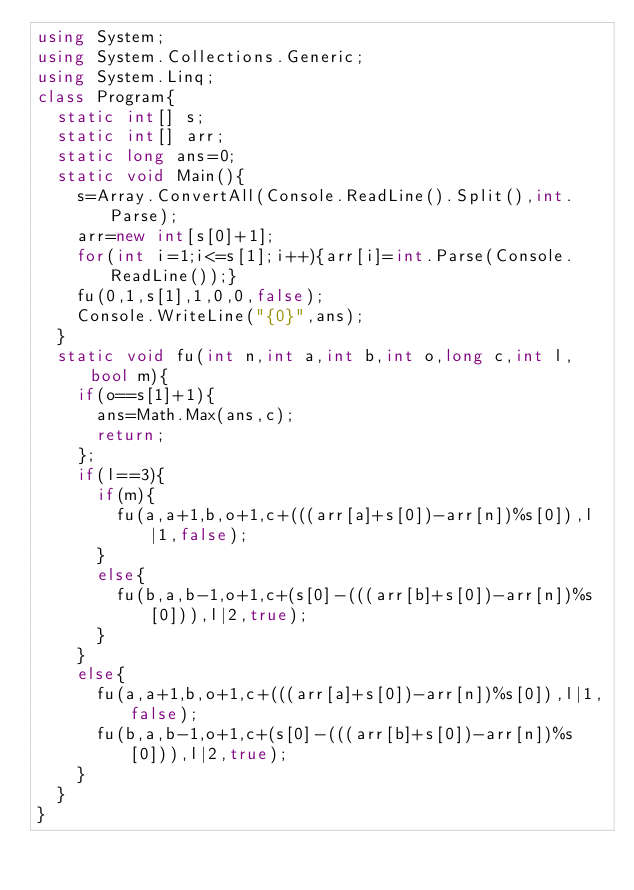<code> <loc_0><loc_0><loc_500><loc_500><_C#_>using System;
using System.Collections.Generic;
using System.Linq;
class Program{
	static int[] s;
	static int[] arr;
	static long ans=0;
	static void Main(){
		s=Array.ConvertAll(Console.ReadLine().Split(),int.Parse);
		arr=new int[s[0]+1];
		for(int i=1;i<=s[1];i++){arr[i]=int.Parse(Console.ReadLine());}
		fu(0,1,s[1],1,0,0,false);
		Console.WriteLine("{0}",ans);
	}
	static void fu(int n,int a,int b,int o,long c,int l,bool m){
		if(o==s[1]+1){
			ans=Math.Max(ans,c);
			return;
		};
		if(l==3){
			if(m){
				fu(a,a+1,b,o+1,c+(((arr[a]+s[0])-arr[n])%s[0]),l|1,false);
			}
			else{
				fu(b,a,b-1,o+1,c+(s[0]-(((arr[b]+s[0])-arr[n])%s[0])),l|2,true);
			}
		}
		else{
			fu(a,a+1,b,o+1,c+(((arr[a]+s[0])-arr[n])%s[0]),l|1,false);
			fu(b,a,b-1,o+1,c+(s[0]-(((arr[b]+s[0])-arr[n])%s[0])),l|2,true);
		}
	}
}</code> 